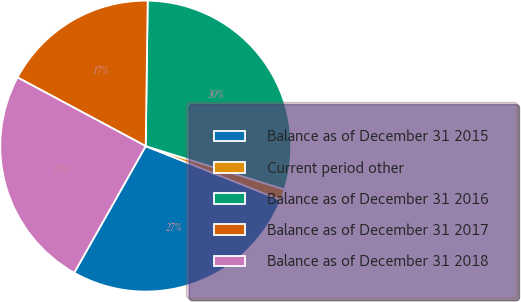<chart> <loc_0><loc_0><loc_500><loc_500><pie_chart><fcel>Balance as of December 31 2015<fcel>Current period other<fcel>Balance as of December 31 2016<fcel>Balance as of December 31 2017<fcel>Balance as of December 31 2018<nl><fcel>27.13%<fcel>1.23%<fcel>29.6%<fcel>17.39%<fcel>24.65%<nl></chart> 